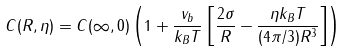Convert formula to latex. <formula><loc_0><loc_0><loc_500><loc_500>C ( { R } , \eta ) = C ( { \infty } , 0 ) \left ( 1 + \frac { v _ { b } } { k _ { B } T } \left [ \frac { 2 \sigma } { R } - \frac { { \eta } k _ { B } T } { ( 4 { \pi } / 3 ) R ^ { 3 } } \right ] \right )</formula> 